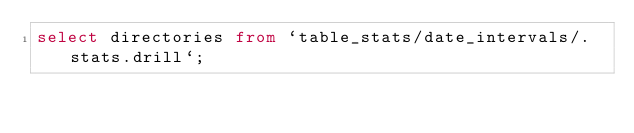<code> <loc_0><loc_0><loc_500><loc_500><_SQL_>select directories from `table_stats/date_intervals/.stats.drill`;
</code> 